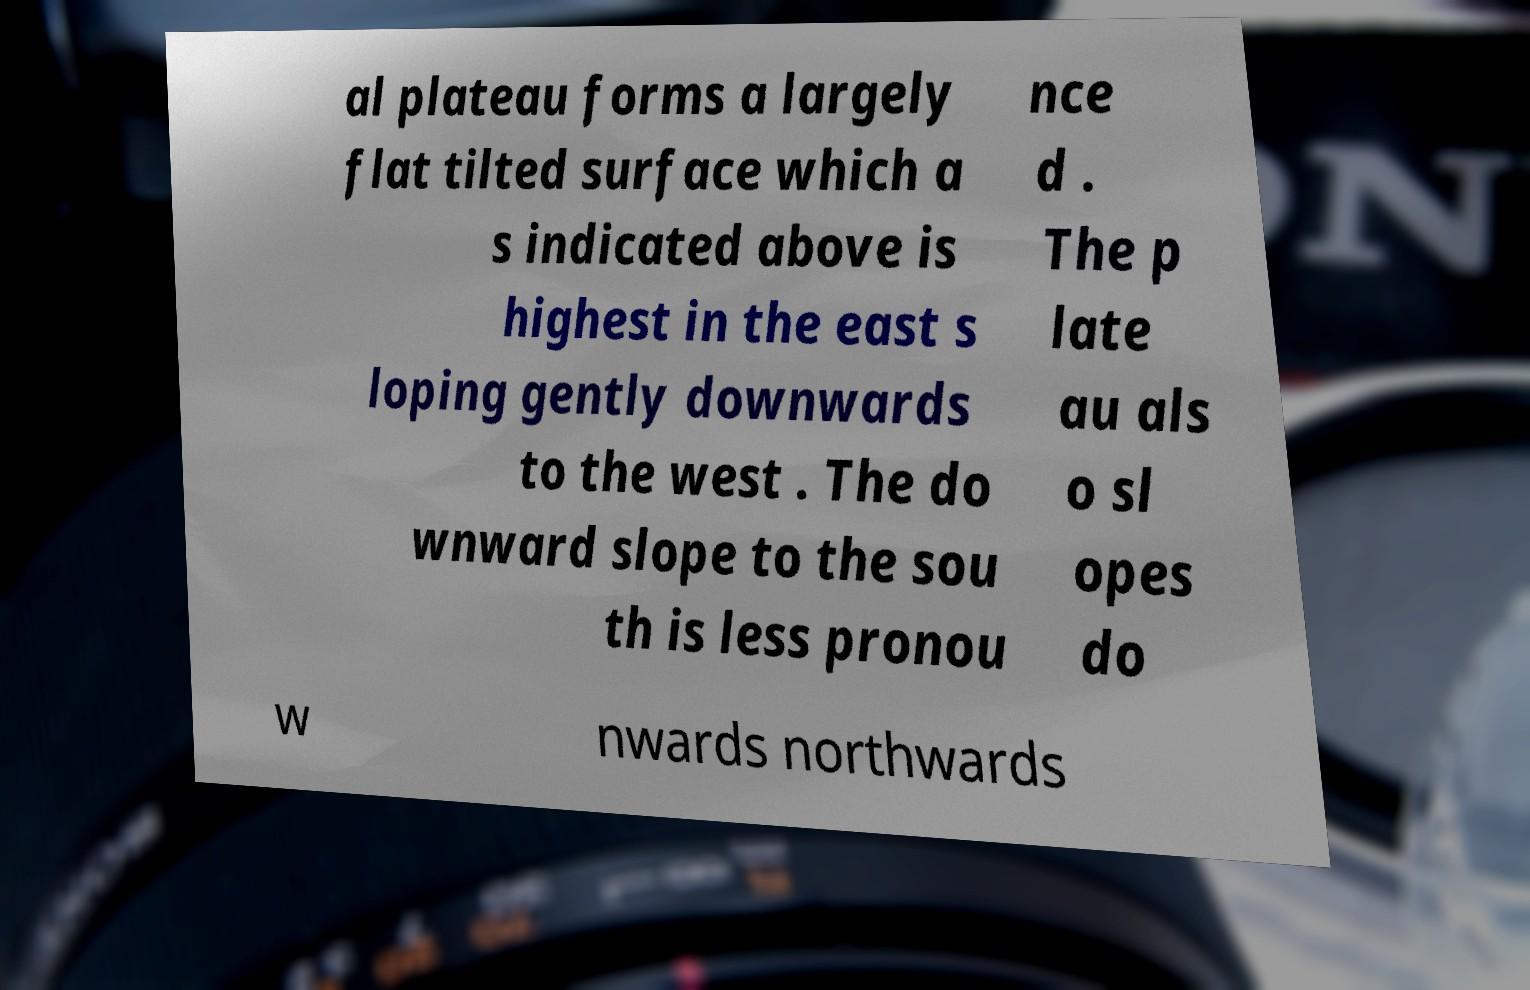Please read and relay the text visible in this image. What does it say? al plateau forms a largely flat tilted surface which a s indicated above is highest in the east s loping gently downwards to the west . The do wnward slope to the sou th is less pronou nce d . The p late au als o sl opes do w nwards northwards 